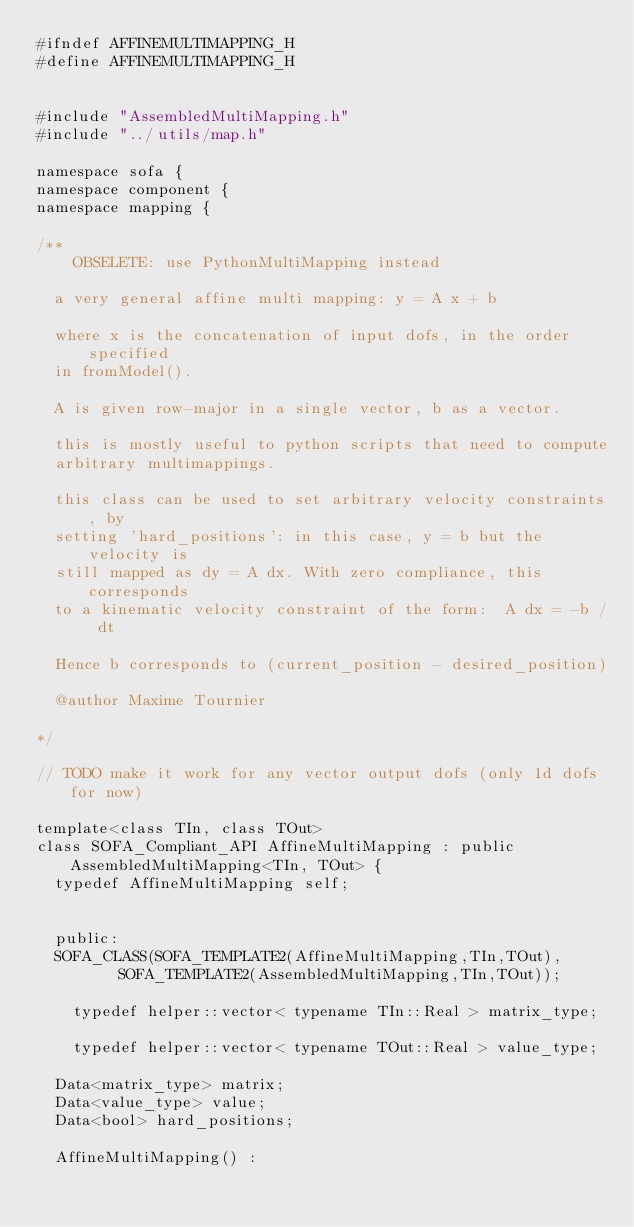<code> <loc_0><loc_0><loc_500><loc_500><_C_>#ifndef AFFINEMULTIMAPPING_H
#define AFFINEMULTIMAPPING_H


#include "AssembledMultiMapping.h"
#include "../utils/map.h"

namespace sofa {
namespace component {
namespace mapping {

/** 
    OBSELETE: use PythonMultiMapping instead

	a very general affine multi mapping: y = A x + b
	
	where x is the concatenation of input dofs, in the order specified
	in fromModel().

	A is given row-major in a single vector, b as a vector.

	this is mostly useful to python scripts that need to compute
	arbitrary multimappings.
	
	this class can be used to set arbitrary velocity constraints, by
	setting 'hard_positions': in this case, y = b but the velocity is
	still mapped as dy = A dx. With zero compliance, this corresponds
	to a kinematic velocity constraint of the form:  A dx = -b / dt

	Hence b corresponds to (current_position - desired_position)

	@author Maxime Tournier
	
*/

// TODO make it work for any vector output dofs (only 1d dofs for now)

template<class TIn, class TOut>
class SOFA_Compliant_API AffineMultiMapping : public AssembledMultiMapping<TIn, TOut> {
	typedef AffineMultiMapping self;
	

  public:
	SOFA_CLASS(SOFA_TEMPLATE2(AffineMultiMapping,TIn,TOut), 
			   SOFA_TEMPLATE2(AssembledMultiMapping,TIn,TOut));
	
    typedef helper::vector< typename TIn::Real > matrix_type;
	
    typedef helper::vector< typename TOut::Real > value_type;

	Data<matrix_type> matrix;
	Data<value_type> value;		
	Data<bool> hard_positions;
	
	AffineMultiMapping() :</code> 